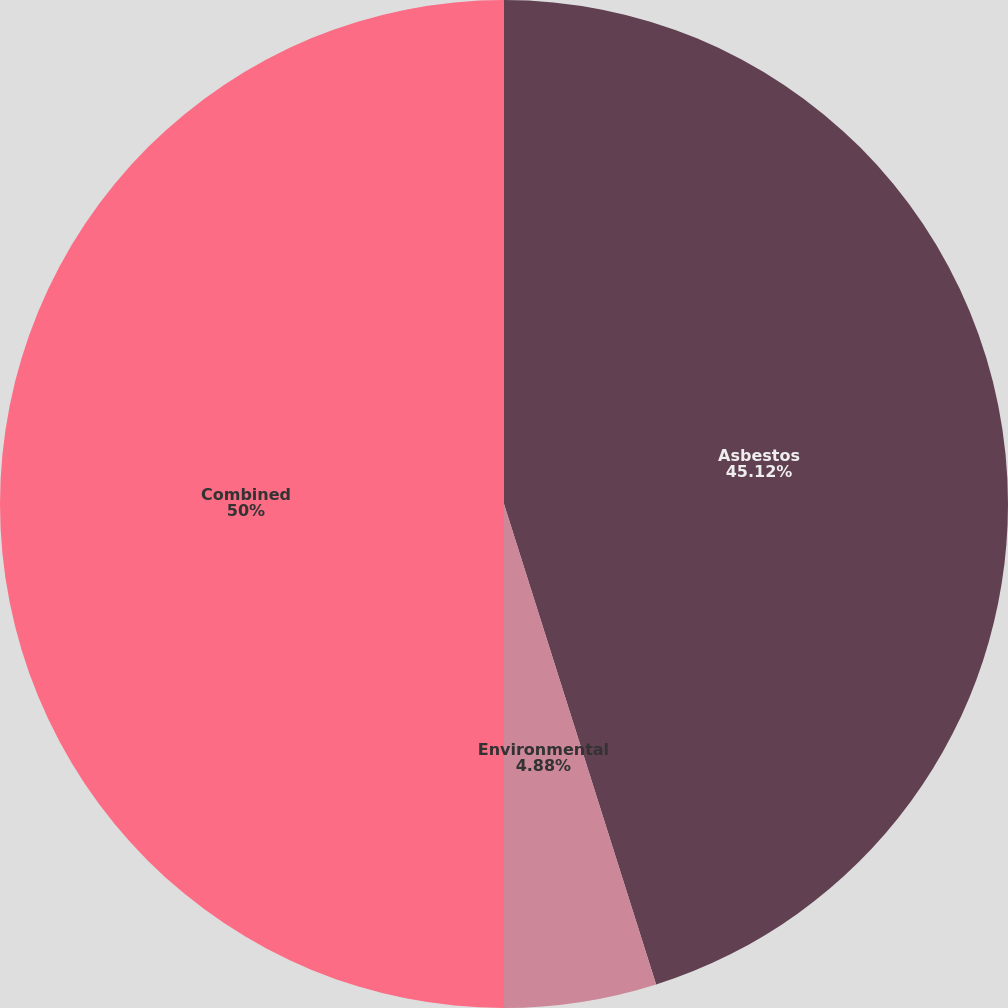Convert chart to OTSL. <chart><loc_0><loc_0><loc_500><loc_500><pie_chart><fcel>Asbestos<fcel>Environmental<fcel>Combined<nl><fcel>45.12%<fcel>4.88%<fcel>50.0%<nl></chart> 